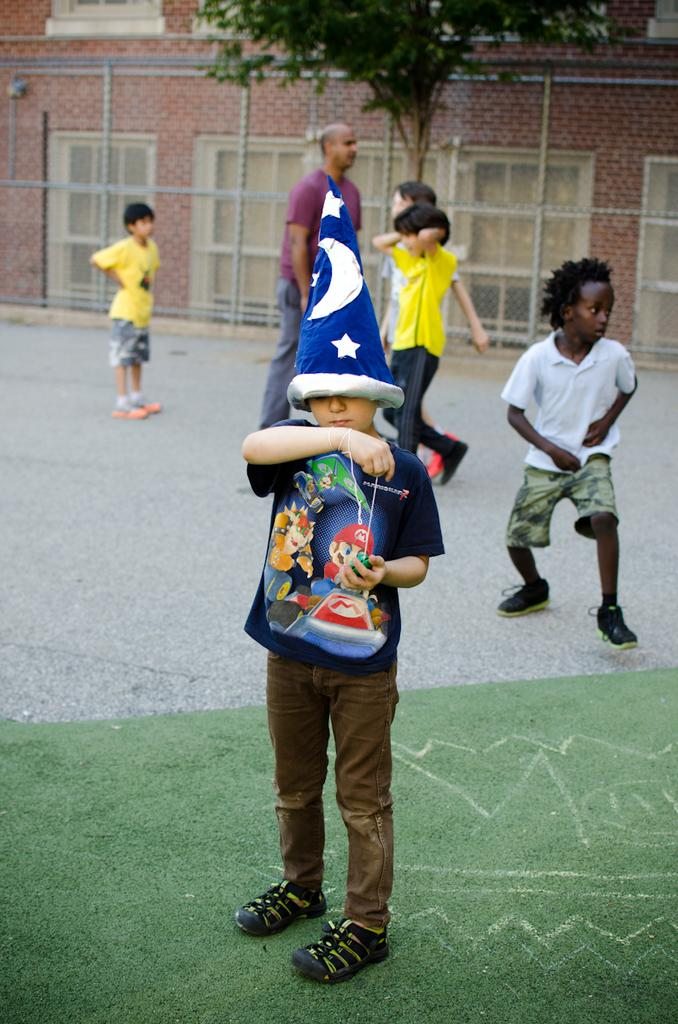How many people are in the image? There are people in the image, but the exact number is not specified. What can be seen in the background of the image? In the background of the image, there is a wall, windows, fencing, and a tree. Can you describe the wall in the background? The wall is a part of the background, but no specific details about its appearance are provided. What type of cabbage is being used as a sack to carry a flock of animals in the image? There is no cabbage, sack, or flock of animals present in the image. 